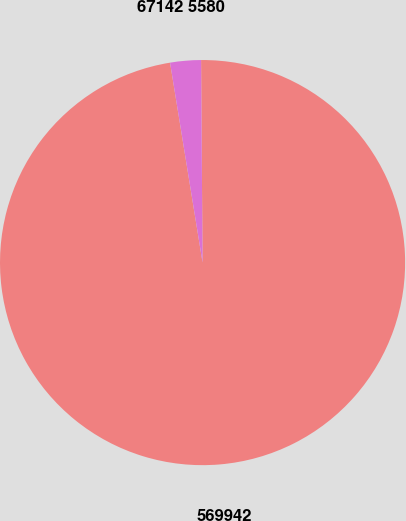Convert chart to OTSL. <chart><loc_0><loc_0><loc_500><loc_500><pie_chart><fcel>569942<fcel>67142 5580<nl><fcel>97.55%<fcel>2.45%<nl></chart> 